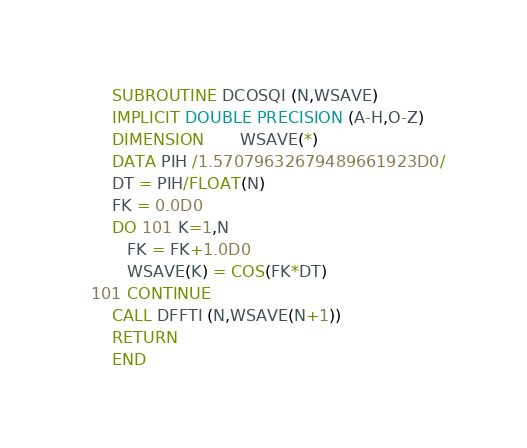Convert code to text. <code><loc_0><loc_0><loc_500><loc_500><_FORTRAN_>      SUBROUTINE DCOSQI (N,WSAVE)
      IMPLICIT DOUBLE PRECISION (A-H,O-Z)
      DIMENSION       WSAVE(*)
      DATA PIH /1.57079632679489661923D0/
      DT = PIH/FLOAT(N)
      FK = 0.0D0
      DO 101 K=1,N
         FK = FK+1.0D0
         WSAVE(K) = COS(FK*DT)
  101 CONTINUE
      CALL DFFTI (N,WSAVE(N+1))
      RETURN
      END
</code> 